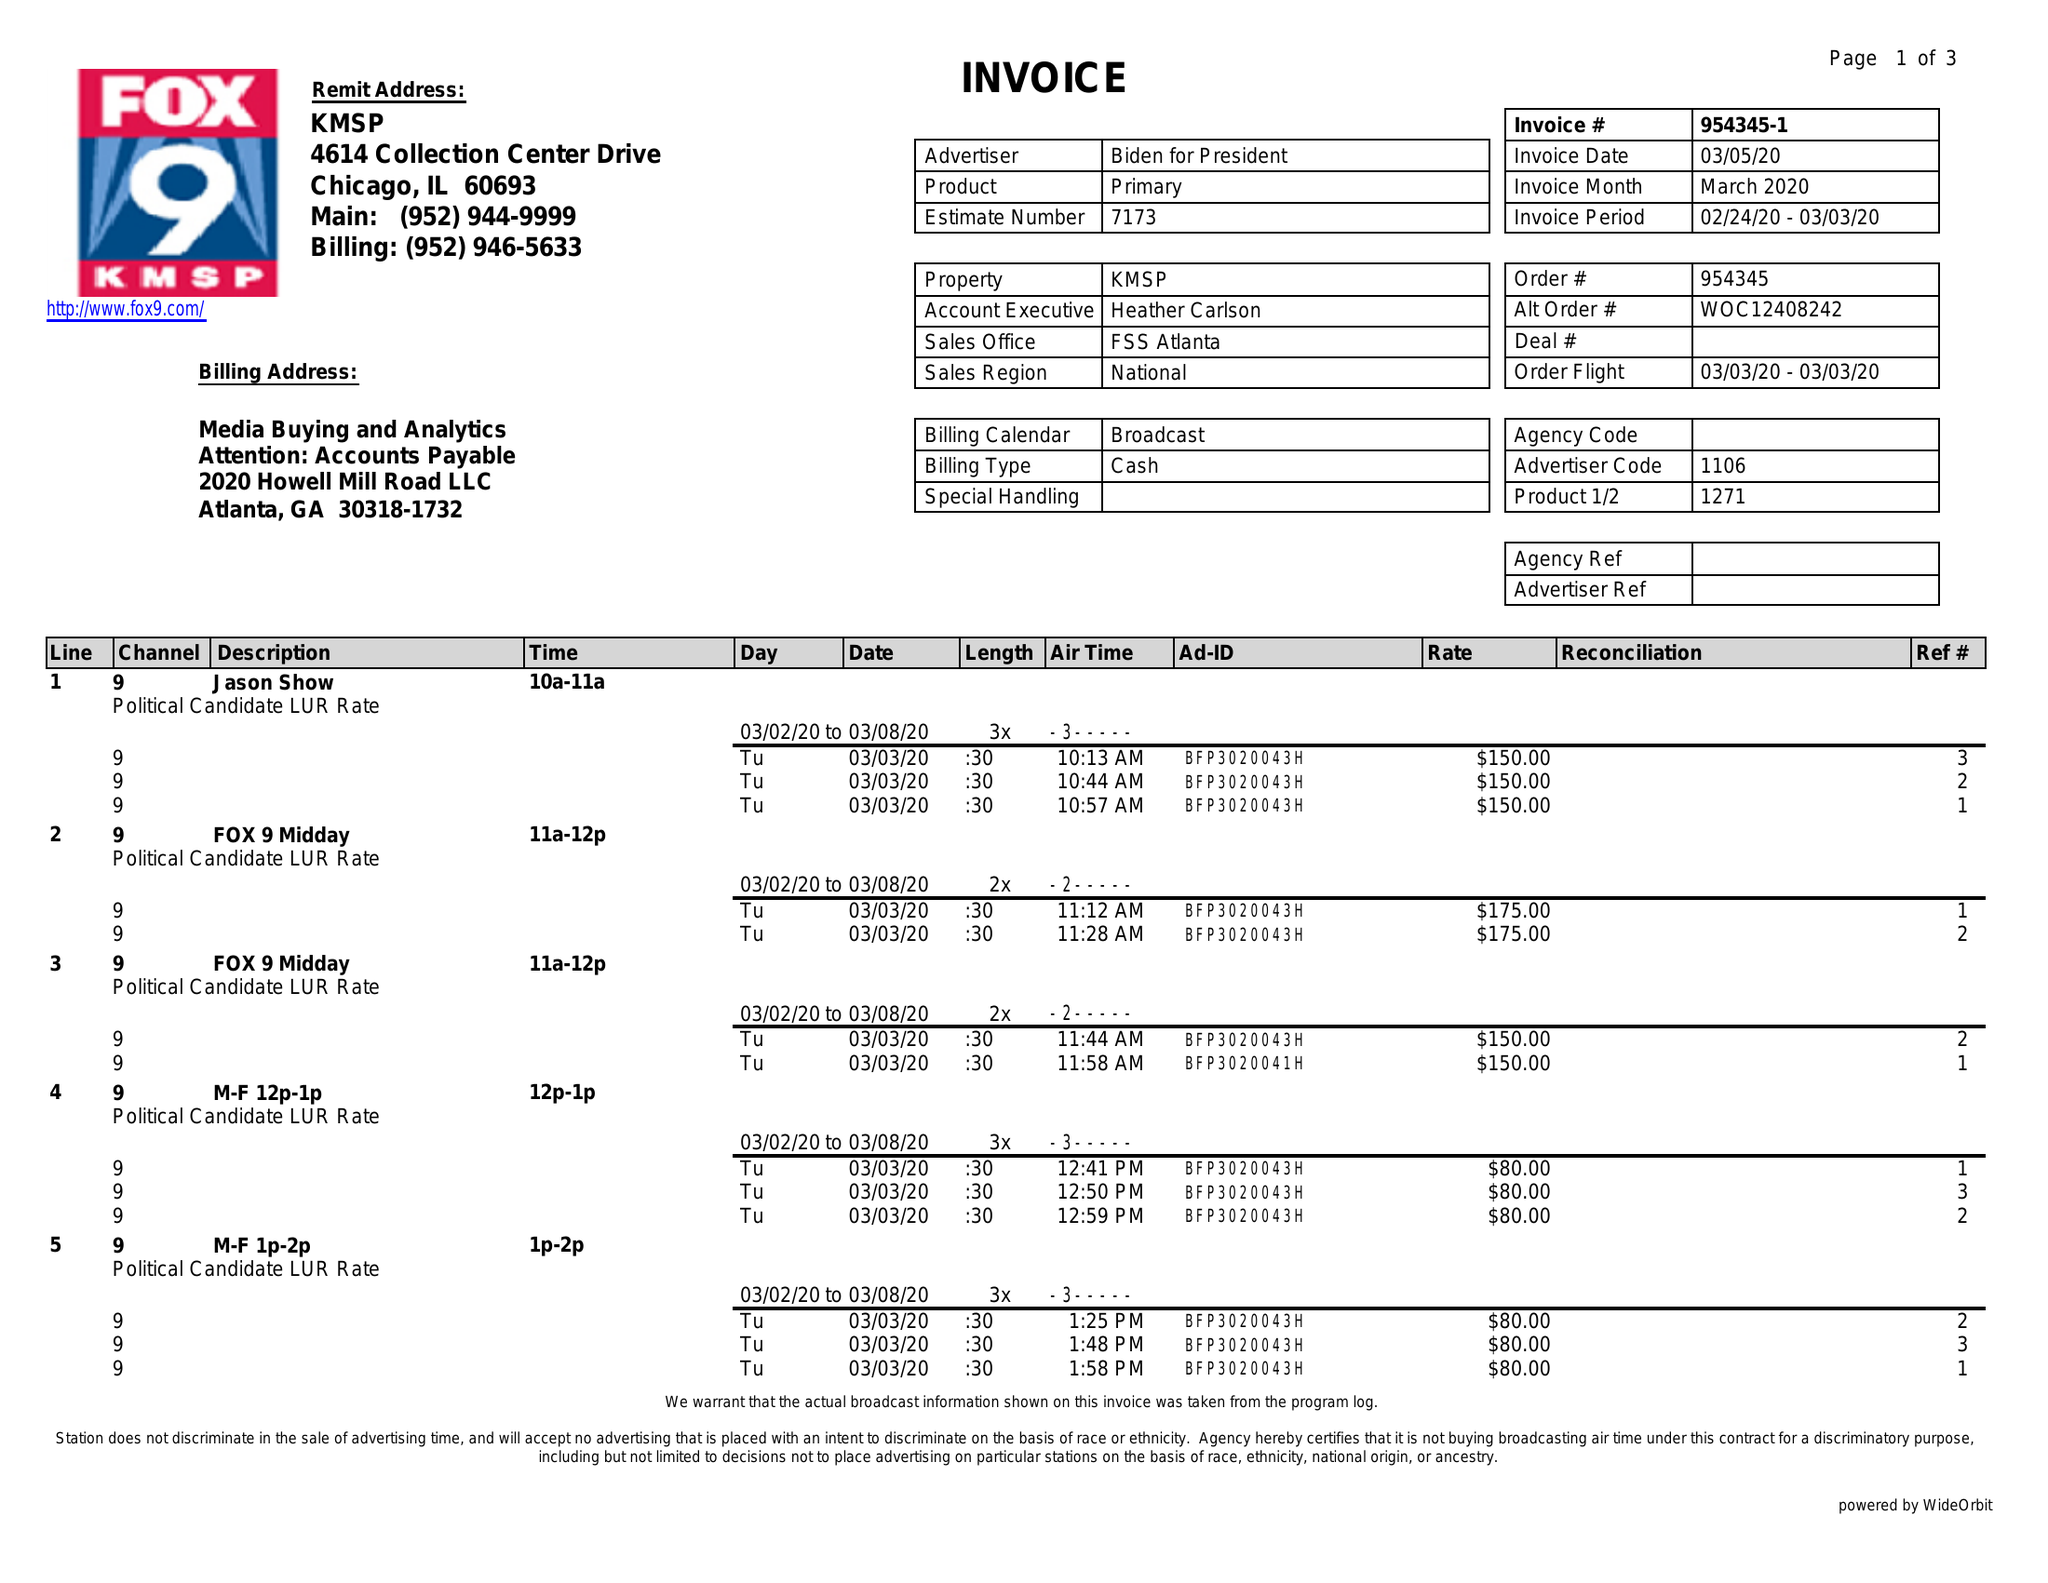What is the value for the contract_num?
Answer the question using a single word or phrase. 954345 